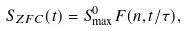Convert formula to latex. <formula><loc_0><loc_0><loc_500><loc_500>S _ { Z F C } ( t ) = S _ { \max } ^ { 0 } F ( n , t / \tau ) ,</formula> 